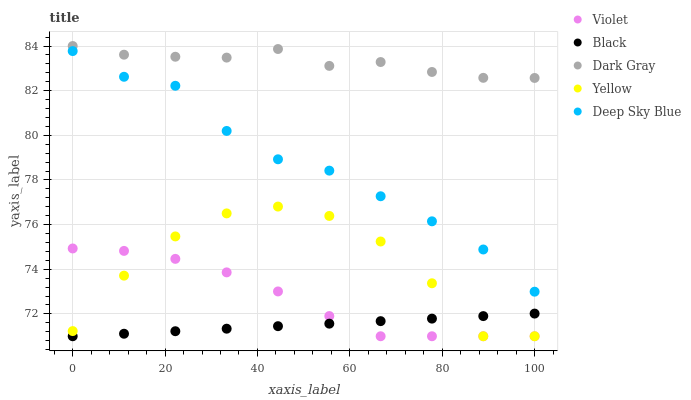Does Black have the minimum area under the curve?
Answer yes or no. Yes. Does Dark Gray have the maximum area under the curve?
Answer yes or no. Yes. Does Deep Sky Blue have the minimum area under the curve?
Answer yes or no. No. Does Deep Sky Blue have the maximum area under the curve?
Answer yes or no. No. Is Black the smoothest?
Answer yes or no. Yes. Is Yellow the roughest?
Answer yes or no. Yes. Is Deep Sky Blue the smoothest?
Answer yes or no. No. Is Deep Sky Blue the roughest?
Answer yes or no. No. Does Black have the lowest value?
Answer yes or no. Yes. Does Deep Sky Blue have the lowest value?
Answer yes or no. No. Does Dark Gray have the highest value?
Answer yes or no. Yes. Does Deep Sky Blue have the highest value?
Answer yes or no. No. Is Violet less than Dark Gray?
Answer yes or no. Yes. Is Deep Sky Blue greater than Yellow?
Answer yes or no. Yes. Does Yellow intersect Violet?
Answer yes or no. Yes. Is Yellow less than Violet?
Answer yes or no. No. Is Yellow greater than Violet?
Answer yes or no. No. Does Violet intersect Dark Gray?
Answer yes or no. No. 